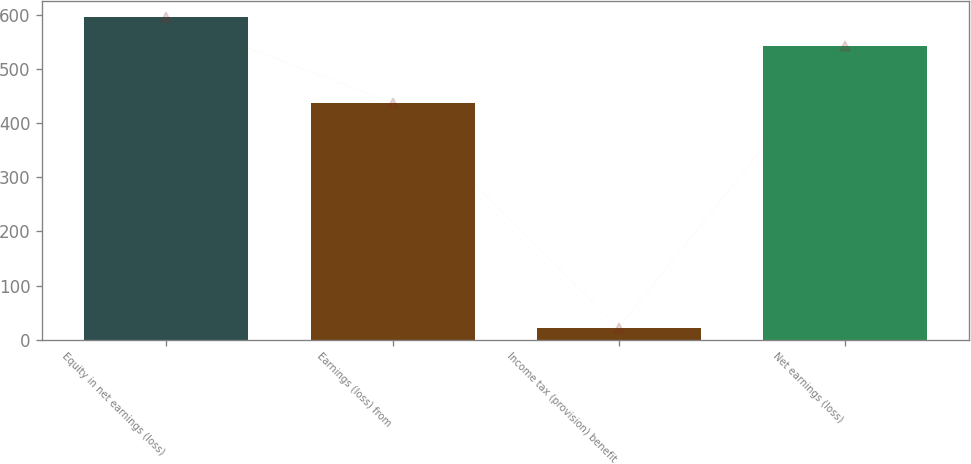Convert chart to OTSL. <chart><loc_0><loc_0><loc_500><loc_500><bar_chart><fcel>Equity in net earnings (loss)<fcel>Earnings (loss) from<fcel>Income tax (provision) benefit<fcel>Net earnings (loss)<nl><fcel>596.6<fcel>437.9<fcel>22<fcel>543.7<nl></chart> 